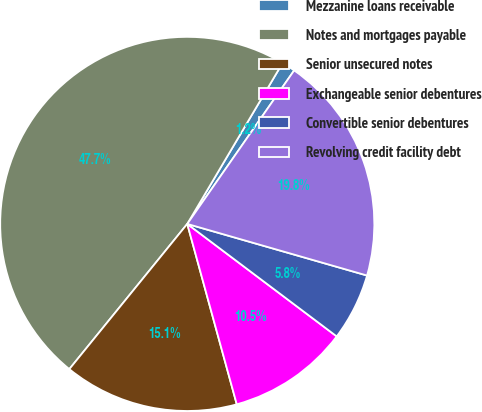<chart> <loc_0><loc_0><loc_500><loc_500><pie_chart><fcel>Mezzanine loans receivable<fcel>Notes and mortgages payable<fcel>Senior unsecured notes<fcel>Exchangeable senior debentures<fcel>Convertible senior debentures<fcel>Revolving credit facility debt<nl><fcel>1.17%<fcel>47.66%<fcel>15.12%<fcel>10.47%<fcel>5.82%<fcel>19.77%<nl></chart> 